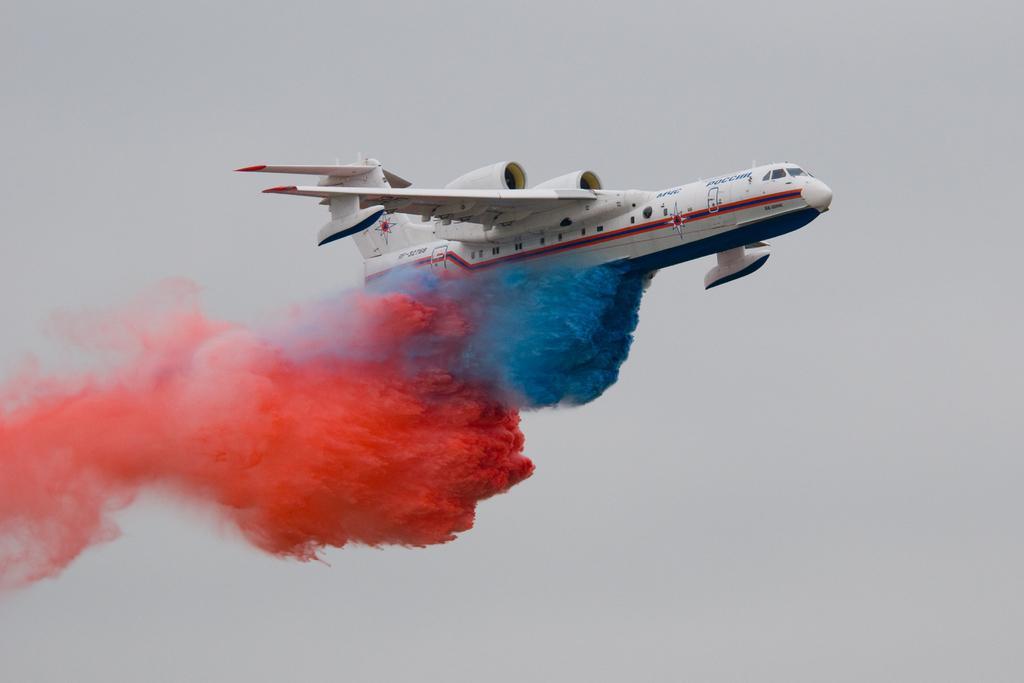In one or two sentences, can you explain what this image depicts? In the middle of the image I can see a plane and colors are in the air. In the background of the image there is sky.  